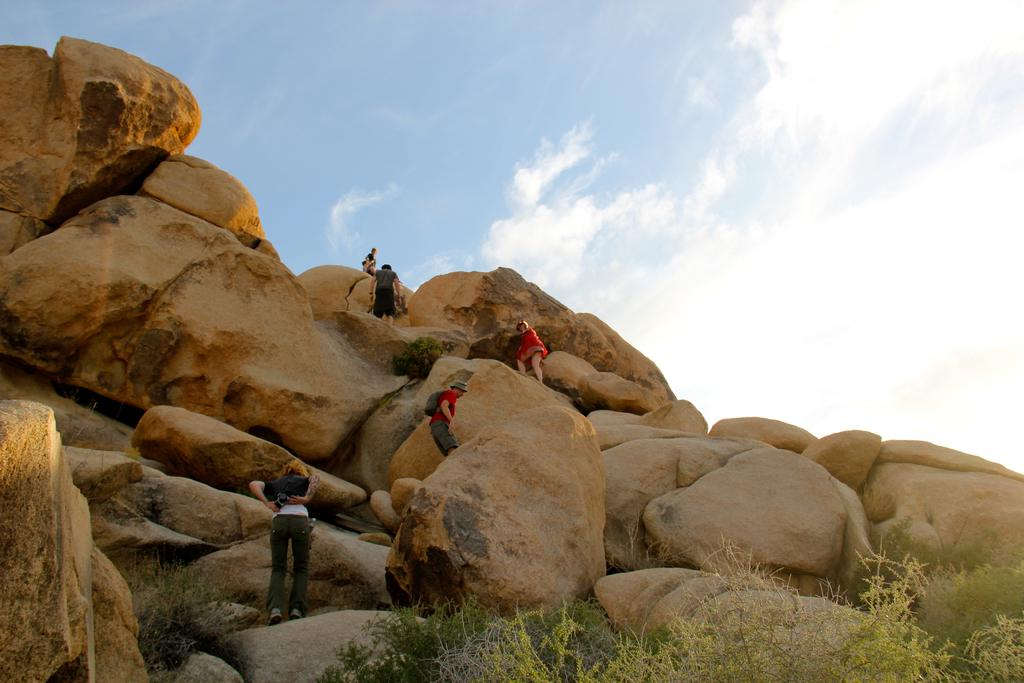Who or what can be seen in the image? There are people in the image. What are the people doing in the image? The people are climbing rocks. What type of vegetation is present at the bottom of the image? There are trees at the bottom of the image. What can be seen in the distance in the image? The sky is visible in the background of the image. What type of rake is being used by the people in the image? There is no rake present in the image; the people are climbing rocks. Can you tell me how many apples are visible in the image? There are no apples present in the image. 